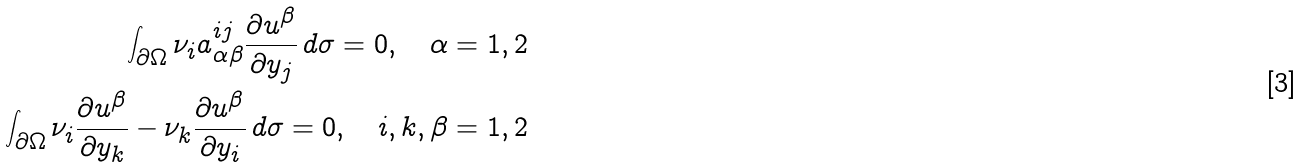<formula> <loc_0><loc_0><loc_500><loc_500>\int _ { \partial \Omega } \nu _ { i } a ^ { i j } _ { \alpha \beta } \frac { \partial u ^ { \beta } } { \partial y _ { j } } \, d \sigma = 0 , \quad \alpha = 1 , 2 \\ \int _ { \partial \Omega } \nu _ { i } \frac { \partial u ^ { \beta } } { \partial y _ { k } } - \nu _ { k } \frac { \partial u ^ { \beta } } { \partial y _ { i } } \, d \sigma = 0 , \quad i , k , \beta = 1 , 2</formula> 